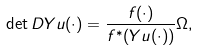<formula> <loc_0><loc_0><loc_500><loc_500>\det D Y u ( \cdot ) = \frac { f ( \cdot ) } { f ^ { * } ( Y u ( \cdot ) ) } \Omega ,</formula> 